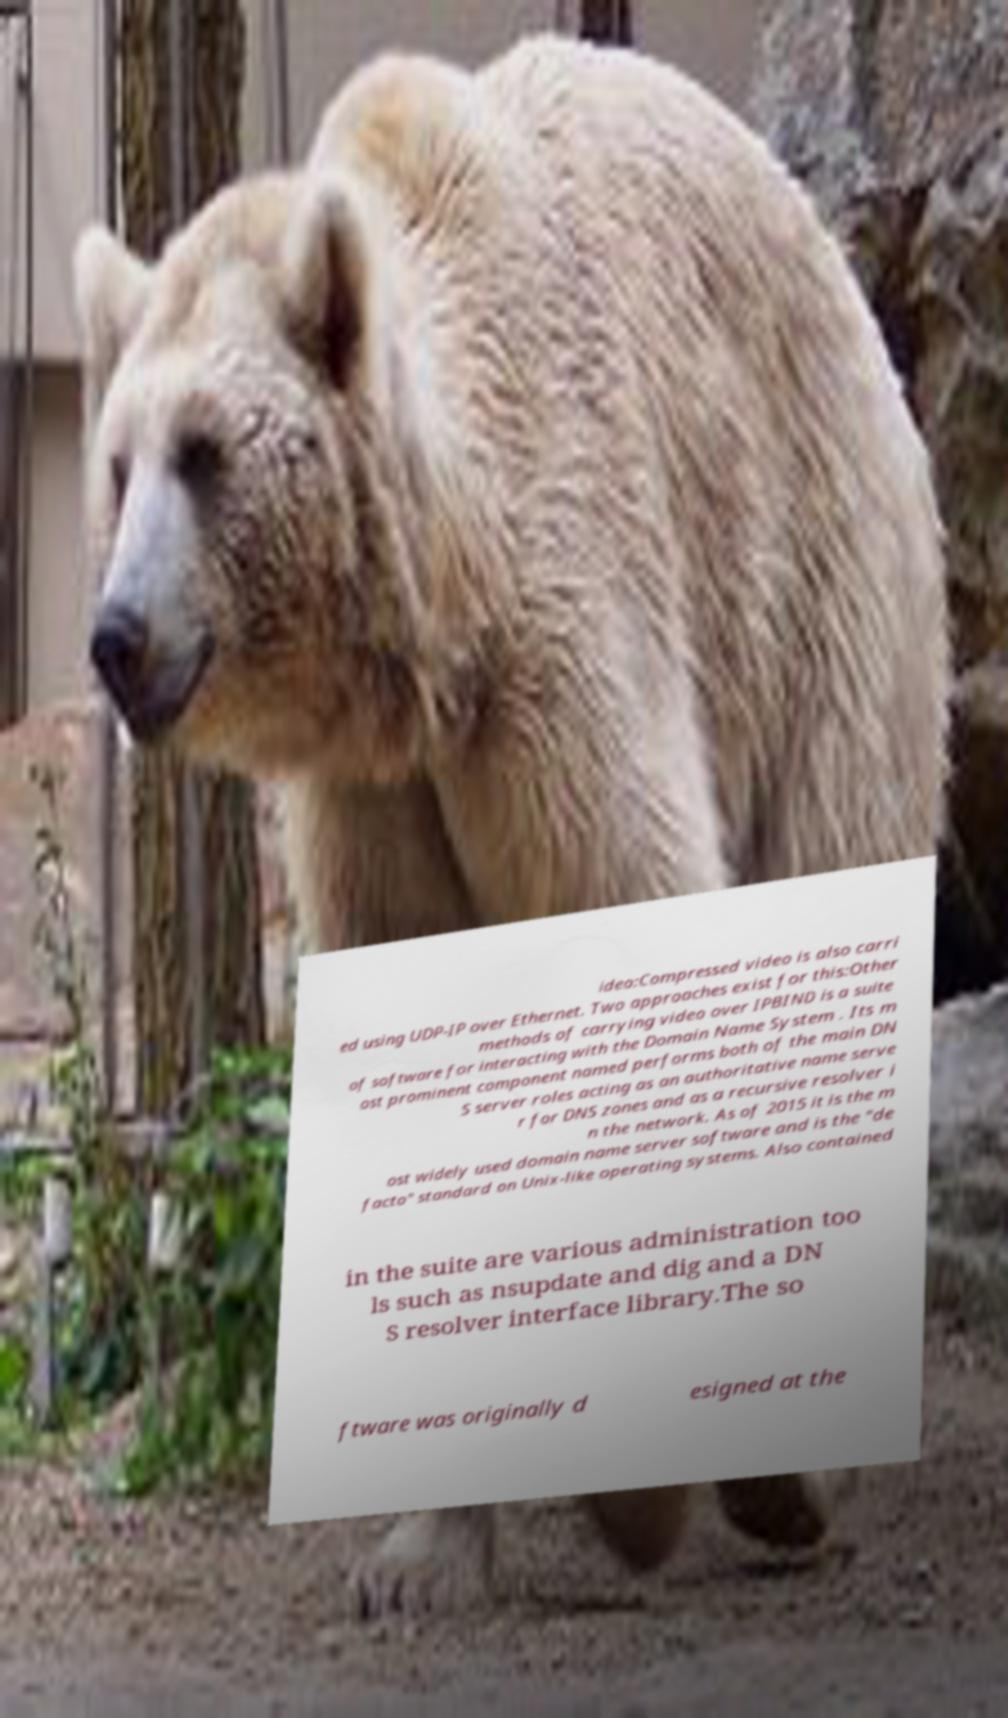Can you accurately transcribe the text from the provided image for me? ideo:Compressed video is also carri ed using UDP-IP over Ethernet. Two approaches exist for this:Other methods of carrying video over IPBIND is a suite of software for interacting with the Domain Name System . Its m ost prominent component named performs both of the main DN S server roles acting as an authoritative name serve r for DNS zones and as a recursive resolver i n the network. As of 2015 it is the m ost widely used domain name server software and is the "de facto" standard on Unix-like operating systems. Also contained in the suite are various administration too ls such as nsupdate and dig and a DN S resolver interface library.The so ftware was originally d esigned at the 